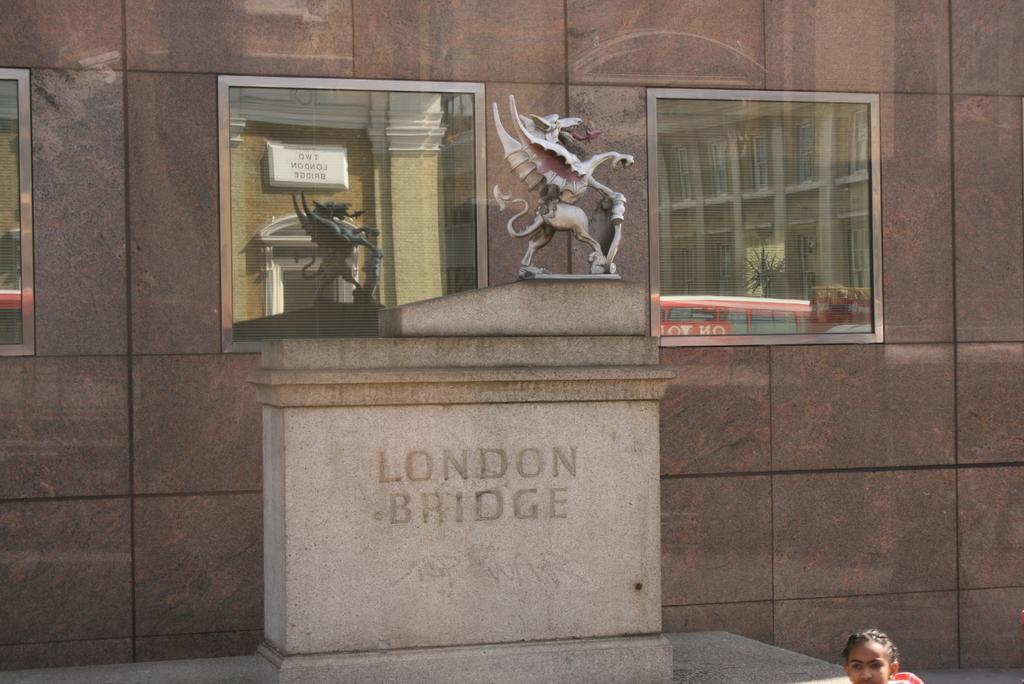Could you give a brief overview of what you see in this image? In this image there is a memorial. There is text on the memorial. On the top of the memorial there is a sculpture. Behind the memorial there is a wall. There are glass windows to the wall. In the reflection of the windows there are buildings, boards, a bus and a plant. In the bottom right there is a face of a person. 